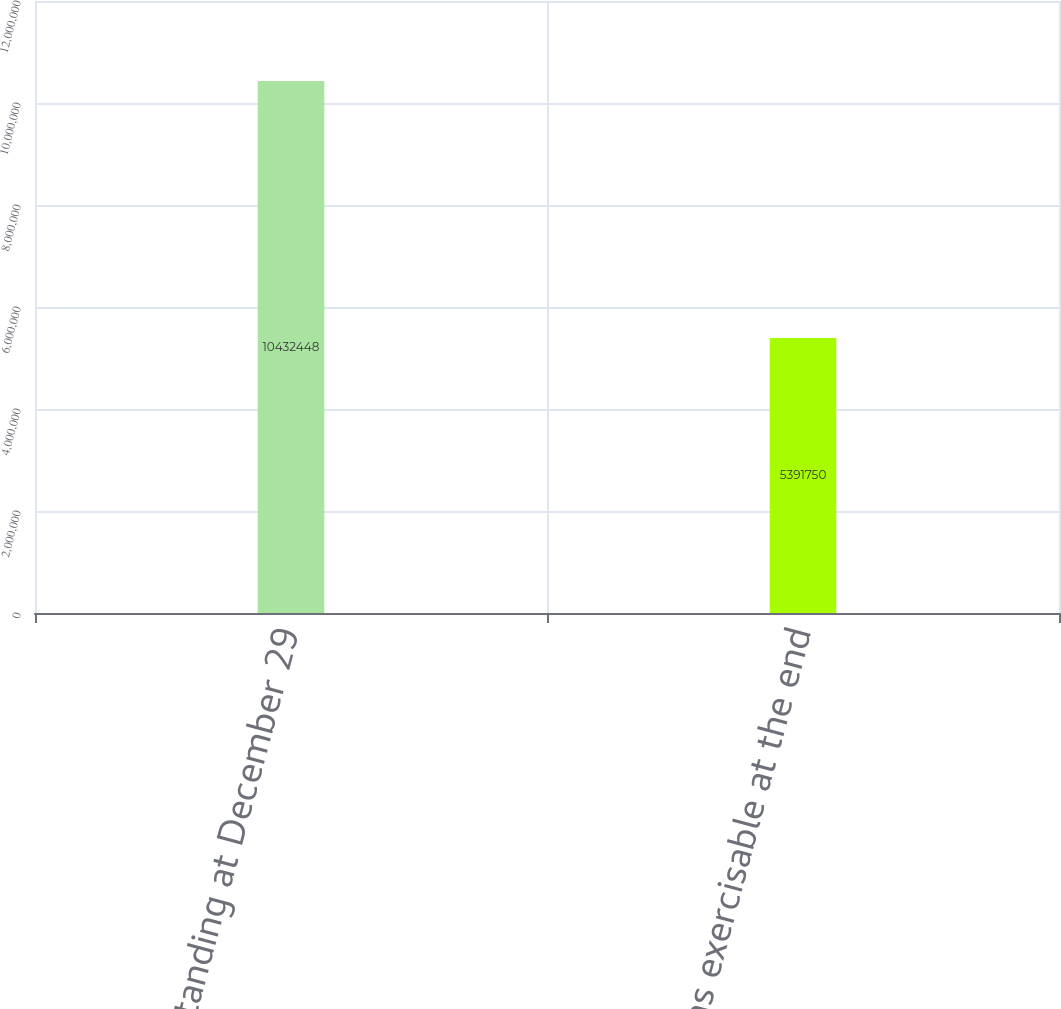<chart> <loc_0><loc_0><loc_500><loc_500><bar_chart><fcel>Outstanding at December 29<fcel>Options exercisable at the end<nl><fcel>1.04324e+07<fcel>5.39175e+06<nl></chart> 